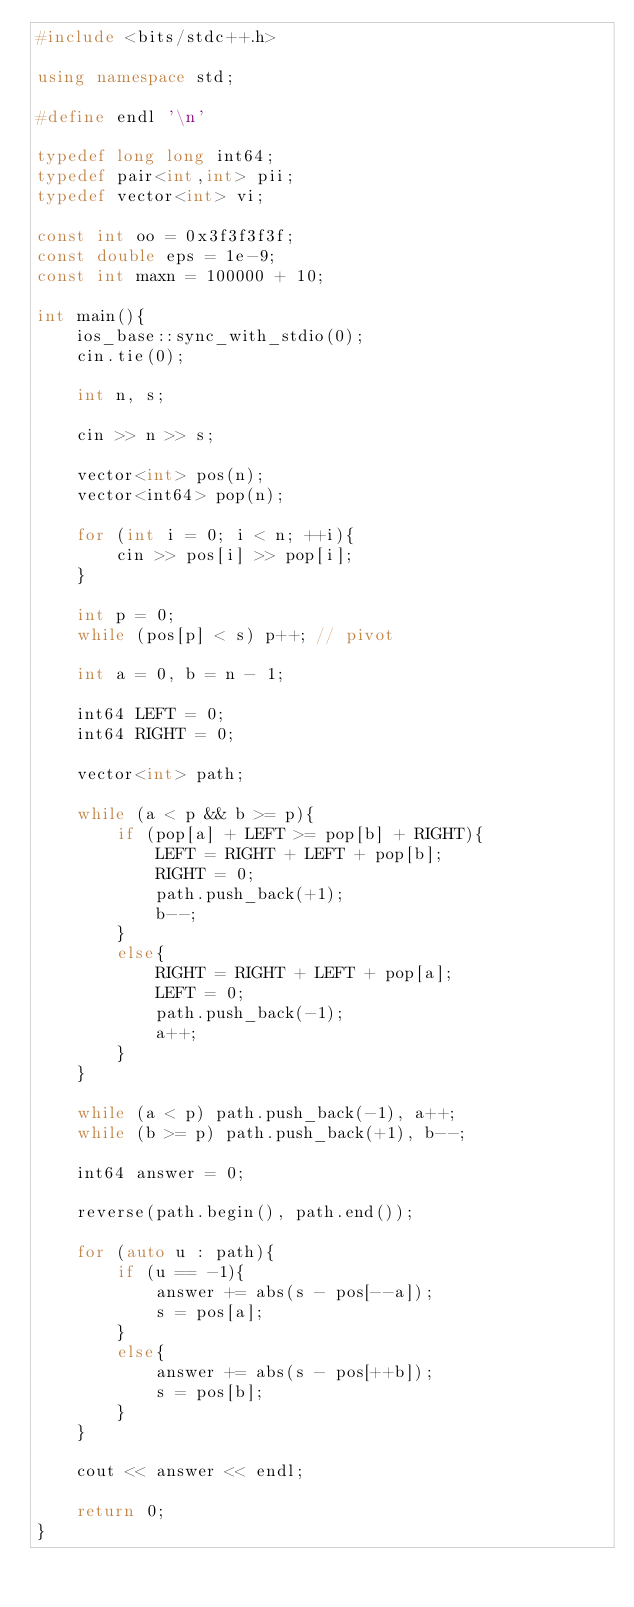Convert code to text. <code><loc_0><loc_0><loc_500><loc_500><_C++_>#include <bits/stdc++.h>

using namespace std;

#define endl '\n'

typedef long long int64;
typedef pair<int,int> pii;
typedef vector<int> vi;

const int oo = 0x3f3f3f3f;
const double eps = 1e-9;
const int maxn = 100000 + 10;

int main(){
    ios_base::sync_with_stdio(0);
    cin.tie(0);

    int n, s;

    cin >> n >> s;

    vector<int> pos(n);
    vector<int64> pop(n);

    for (int i = 0; i < n; ++i){
        cin >> pos[i] >> pop[i];
    }

    int p = 0;
    while (pos[p] < s) p++; // pivot

    int a = 0, b = n - 1;

    int64 LEFT = 0;
    int64 RIGHT = 0;

    vector<int> path;

    while (a < p && b >= p){
        if (pop[a] + LEFT >= pop[b] + RIGHT){
            LEFT = RIGHT + LEFT + pop[b];
            RIGHT = 0;
            path.push_back(+1);
            b--;
        }
        else{
            RIGHT = RIGHT + LEFT + pop[a];
            LEFT = 0;
            path.push_back(-1);
            a++;
        }
    }

    while (a < p) path.push_back(-1), a++;
    while (b >= p) path.push_back(+1), b--;

    int64 answer = 0;

    reverse(path.begin(), path.end());

    for (auto u : path){
        if (u == -1){
            answer += abs(s - pos[--a]);
            s = pos[a];
        }
        else{
            answer += abs(s - pos[++b]);
            s = pos[b];
        }
    }

    cout << answer << endl;

    return 0;
}</code> 